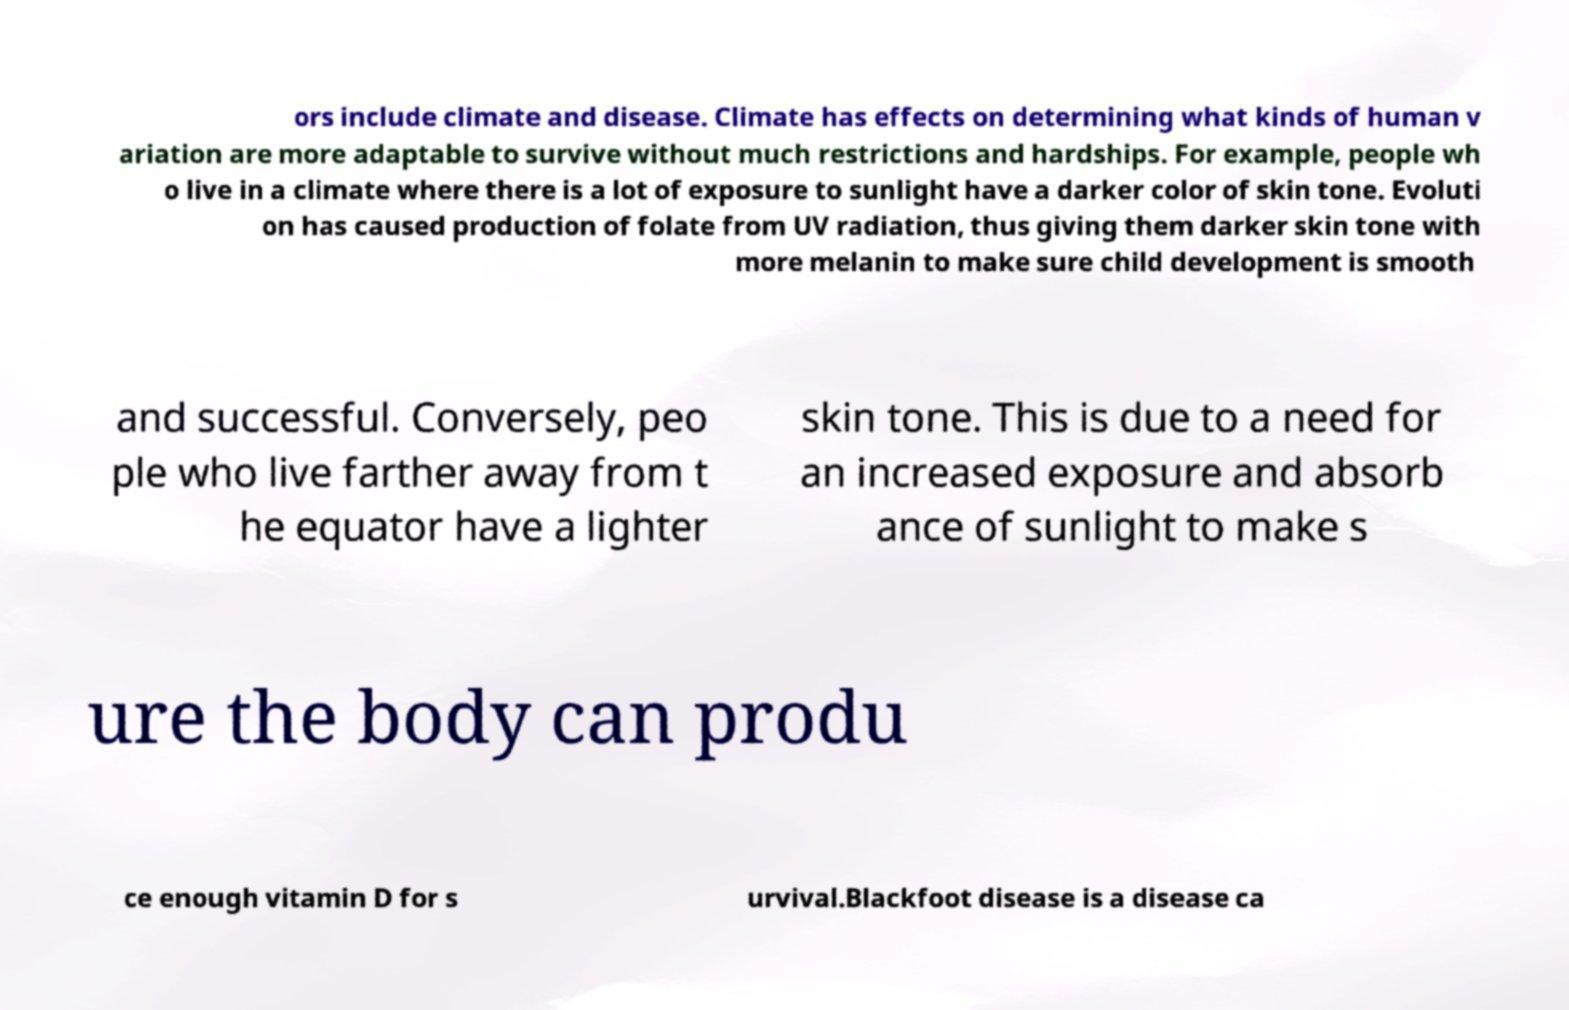What messages or text are displayed in this image? I need them in a readable, typed format. ors include climate and disease. Climate has effects on determining what kinds of human v ariation are more adaptable to survive without much restrictions and hardships. For example, people wh o live in a climate where there is a lot of exposure to sunlight have a darker color of skin tone. Evoluti on has caused production of folate from UV radiation, thus giving them darker skin tone with more melanin to make sure child development is smooth and successful. Conversely, peo ple who live farther away from t he equator have a lighter skin tone. This is due to a need for an increased exposure and absorb ance of sunlight to make s ure the body can produ ce enough vitamin D for s urvival.Blackfoot disease is a disease ca 